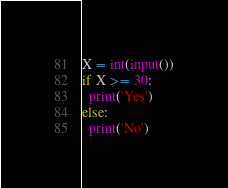Convert code to text. <code><loc_0><loc_0><loc_500><loc_500><_Python_>X = int(input())
if X >= 30:
  print('Yes')
else:
  print('No')</code> 